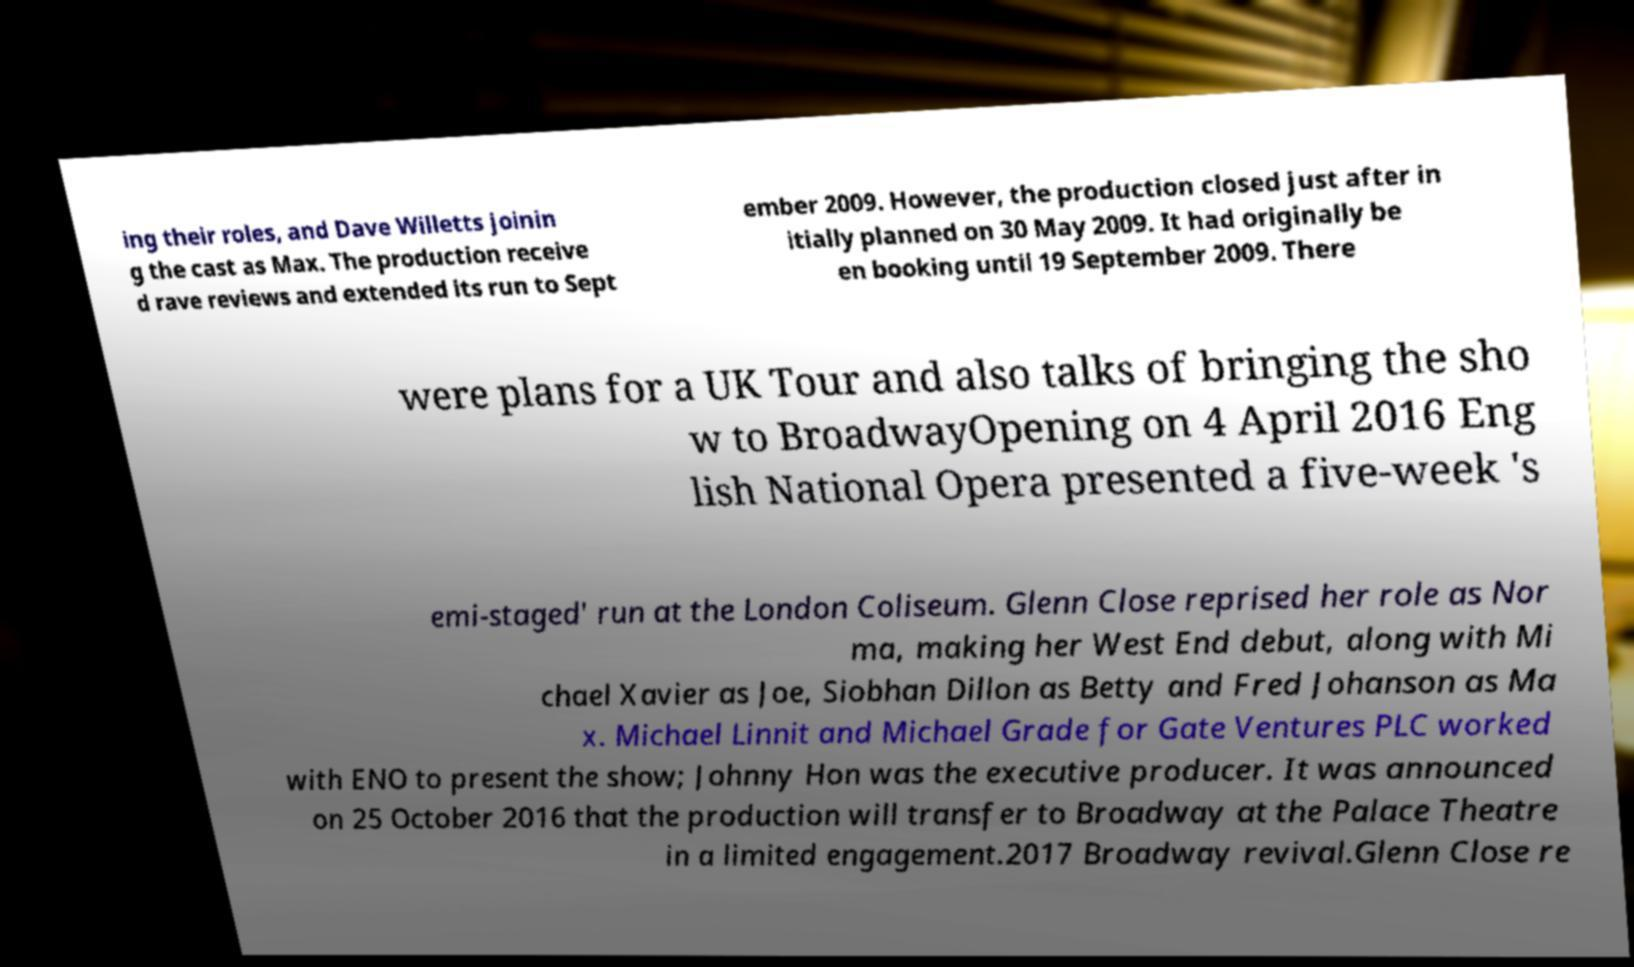What messages or text are displayed in this image? I need them in a readable, typed format. ing their roles, and Dave Willetts joinin g the cast as Max. The production receive d rave reviews and extended its run to Sept ember 2009. However, the production closed just after in itially planned on 30 May 2009. It had originally be en booking until 19 September 2009. There were plans for a UK Tour and also talks of bringing the sho w to BroadwayOpening on 4 April 2016 Eng lish National Opera presented a five-week 's emi-staged' run at the London Coliseum. Glenn Close reprised her role as Nor ma, making her West End debut, along with Mi chael Xavier as Joe, Siobhan Dillon as Betty and Fred Johanson as Ma x. Michael Linnit and Michael Grade for Gate Ventures PLC worked with ENO to present the show; Johnny Hon was the executive producer. It was announced on 25 October 2016 that the production will transfer to Broadway at the Palace Theatre in a limited engagement.2017 Broadway revival.Glenn Close re 